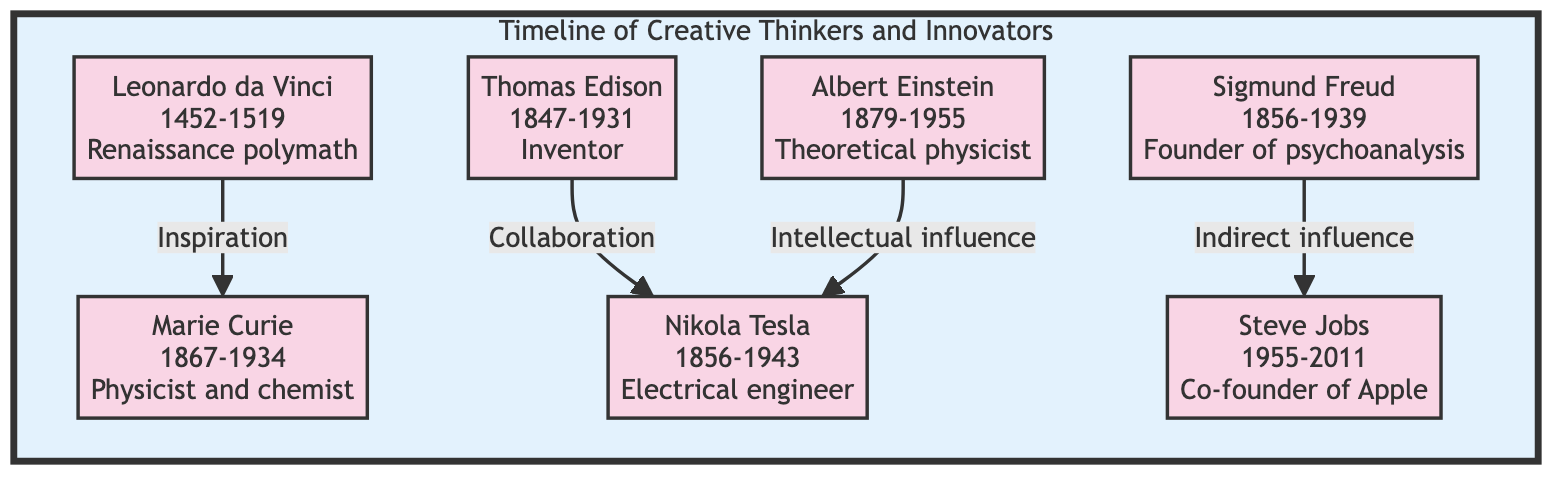What is the birth year of Marie Curie? According to the diagram, Marie Curie is listed with her birth year provided as 1867.
Answer: 1867 Who did Nikola Tesla collaborate with? The diagram states that Nikola Tesla collaborated with Thomas Edison during the early stages of their careers before they pursued their own individual visions.
Answer: Thomas Edison How many creative thinkers are depicted in the diagram? By counting the nodes in the Timeline subgraph, I find that there are a total of seven creative thinkers presented.
Answer: 7 What type of influence did Sigmund Freud have on Steve Jobs? The diagram indicates that Freud had an indirect influence on Steve Jobs, which suggests a less direct impact but still considerable relevance.
Answer: Indirect influence Which innovator is known for the theory of relativity? The diagram clearly shows that Albert Einstein is noted for developing the theory of relativity, which is a key contribution in theoretical physics.
Answer: Albert Einstein What was the contribution of Leonardo da Vinci to creativity? According to the diagram, Leonardo da Vinci’s contribution involved being a Renaissance polymath, renowned for his blending of art and science, thus paving the way for interdisciplinary creativity.
Answer: Renaissance polymath Who was inspired by Leonardo da Vinci? As mentioned in the diagram, Marie Curie was inspired by Leonardo da Vinci's method of blending disciplines to craft her approach in the scientific arena.
Answer: Marie Curie What relationship type exists between Albert Einstein and Nikola Tesla? The diagram describes the relationship between Albert Einstein and Nikola Tesla as one of intellectual influence, highlighting how Einstein's theories inspired Tesla’s futuristic ideas.
Answer: Intellectual influence 